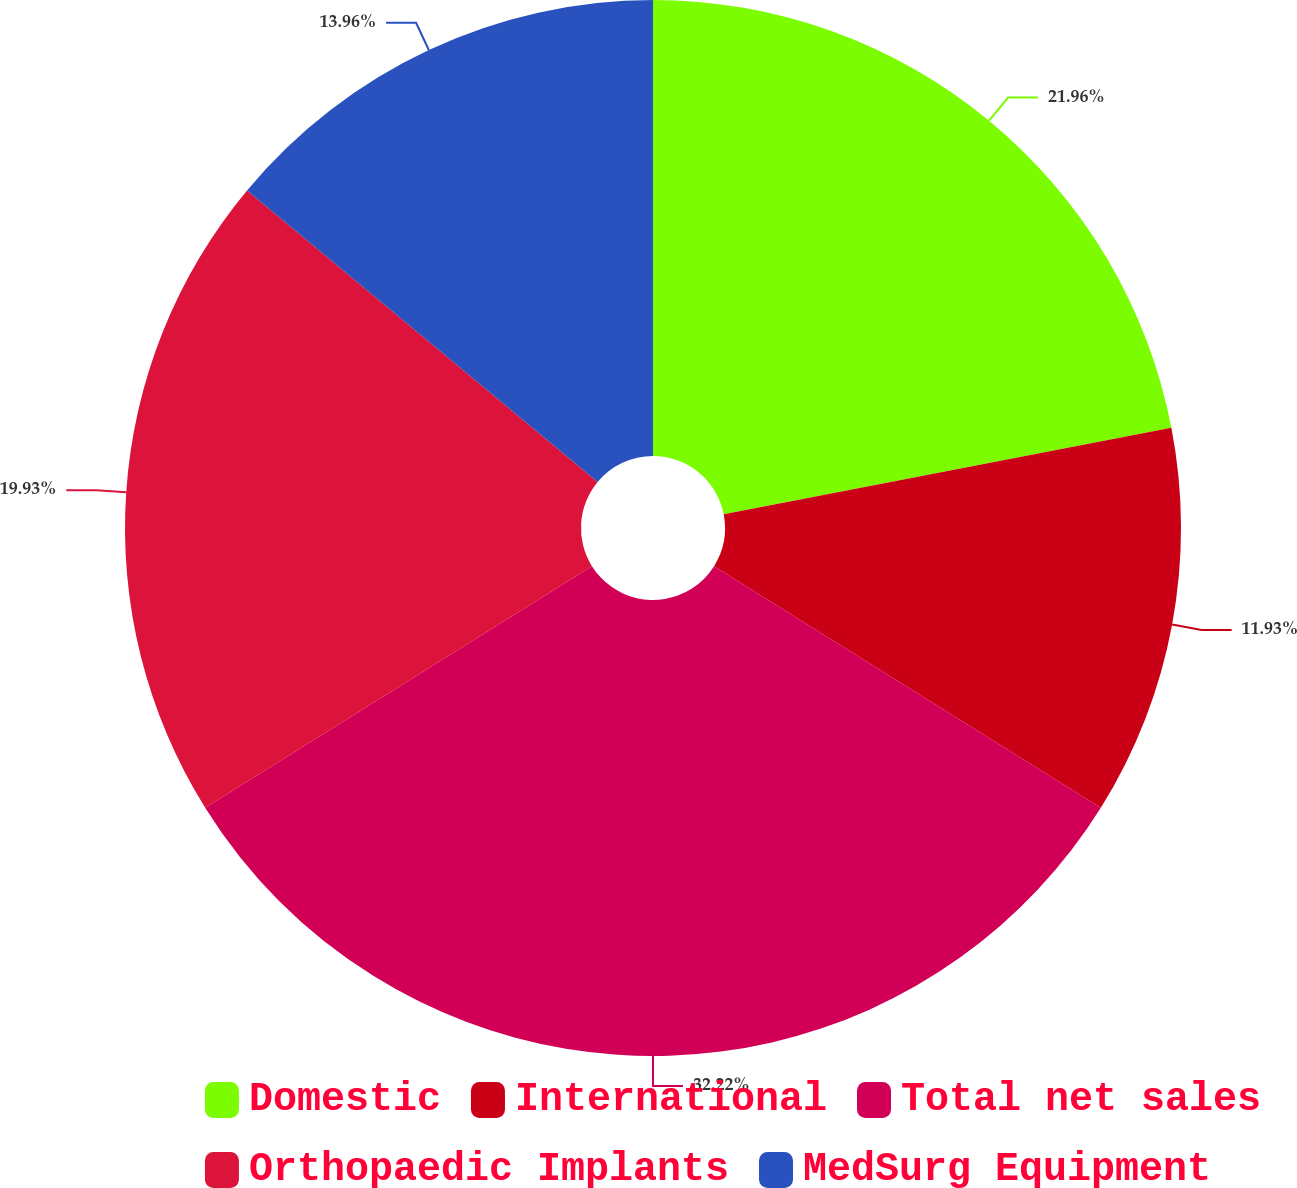Convert chart. <chart><loc_0><loc_0><loc_500><loc_500><pie_chart><fcel>Domestic<fcel>International<fcel>Total net sales<fcel>Orthopaedic Implants<fcel>MedSurg Equipment<nl><fcel>21.96%<fcel>11.93%<fcel>32.23%<fcel>19.93%<fcel>13.96%<nl></chart> 